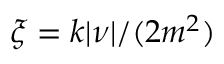<formula> <loc_0><loc_0><loc_500><loc_500>\xi = k | \nu | / ( 2 m ^ { 2 } )</formula> 